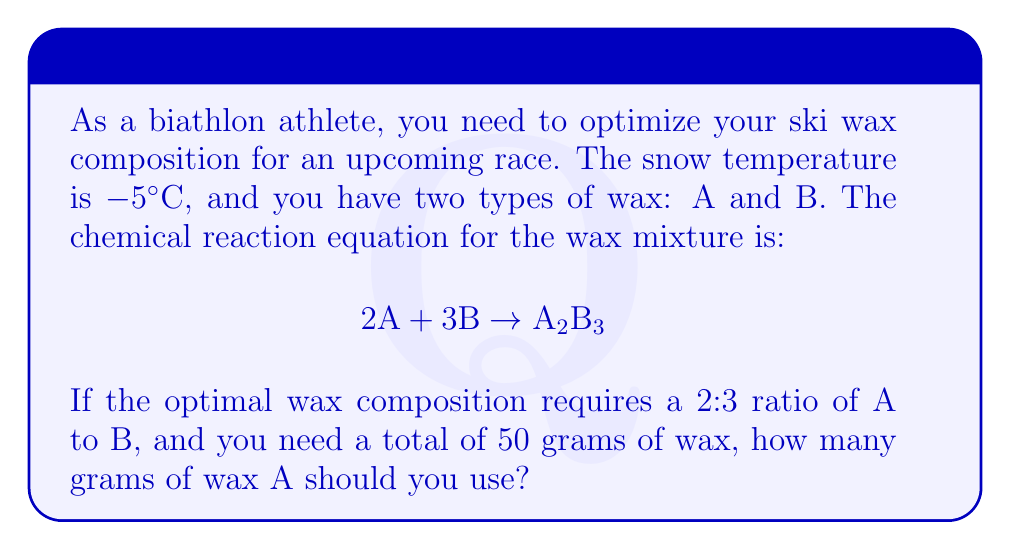Teach me how to tackle this problem. Let's approach this step-by-step:

1) First, we need to understand the given information:
   - The optimal ratio of A:B is 2:3
   - The total amount of wax needed is 50 grams
   - The chemical equation is $2A + 3B \rightarrow A_2B_3$

2) Let's define variables:
   Let $x$ be the number of moles of $A_2B_3$ produced

3) Based on the chemical equation:
   - Moles of A used = $2x$
   - Moles of B used = $3x$

4) The ratio of A:B should be 2:3, so:
   $$\frac{2x}{3x} = \frac{2}{3}$$
   This confirms that our equation matches the required ratio.

5) Now, let's set up an equation for the total mass:
   $$2x \cdot M_A + 3x \cdot M_B = 50$$
   Where $M_A$ and $M_B$ are the molar masses of A and B respectively.

6) We don't know the actual molar masses, but we know their ratio should be 2:3. Let's assume:
   $M_A = 2y$ and $M_B = 3y$ for some value $y$

7) Substituting into our equation:
   $$2x(2y) + 3x(3y) = 50$$
   $$4xy + 9xy = 50$$
   $$13xy = 50$$

8) The actual value of $x$ and $y$ doesn't matter for our purpose. We just need to know what fraction of the total is wax A.

9) Mass of wax A = $2x(2y) = 4xy$
   Fraction of wax A = $\frac{4xy}{13xy} = \frac{4}{13}$

10) Therefore, the amount of wax A needed:
    $$\frac{4}{13} \cdot 50 = \frac{200}{13} \approx 15.38 \text{ grams}$$
Answer: 15.38 grams 